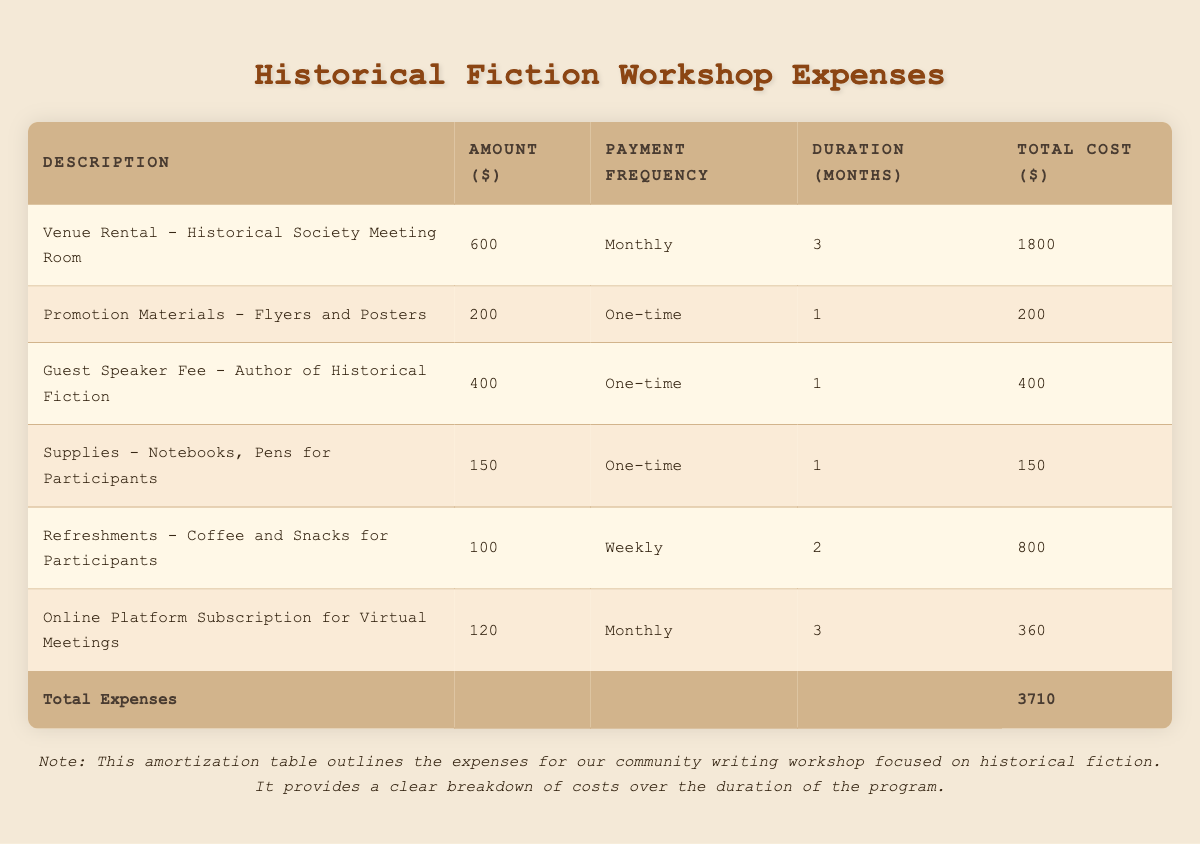What is the total cost of the Venue Rental? The Venue Rental amount is listed as 600, and it is paid monthly for 3 months. The total cost is calculated as 600 multiplied by 3, which equals 1800.
Answer: 1800 How much did we spend on Refreshments? The Refreshments cost 100 per week, and they are needed for 2 months. Since there are approximately 4 weeks in a month, the total number of weeks is 2 times 4, which equals 8 weeks. Therefore, 100 multiplied by 8 equals 800.
Answer: 800 Is the Guest Speaker Fee a recurring expense? The Guest Speaker Fee is listed under payment frequency as "One-time," indicating that it is not a recurring expense.
Answer: No What is the total amount spent on Supplies? Supplies are indicated with a one-time cost of 150, so the total amount spent is simply the listed cost, which is 150.
Answer: 150 What is the average amount of the expenses listed in the table? To find the average, you need to add all total costs together: 1800 + 200 + 400 + 150 + 800 + 360 = 3710. Then, divide this sum by the number of expenses, which is 6, to get an average of 3710/6, which equals approximately 618.33.
Answer: 618.33 What is the highest single expense recorded in the table? By comparing the total costs of each entry, the highest expense is from the Venue Rental, which has a total cost of 1800.
Answer: 1800 Was the Online Platform Subscription for Virtual Meetings paid monthly or as a lump sum? The Online Platform Subscription has a payment frequency labeled as "Monthly," indicating that it was not a lump sum but paid regularly over the duration.
Answer: Monthly What would be the total cost if we added one more month to the Refreshments? Currently, Refreshments are planned for 2 months at a cost of 800. Adding another month would add 100 per week for 4 weeks, which is an additional 400. So, the new total would be 800 plus 400, totaling 1200.
Answer: 1200 How many expenses are related to monthly payments? The table shows two expenses that have a monthly payment frequency: Venue Rental and Online Platform Subscription. Therefore, the total is 2.
Answer: 2 